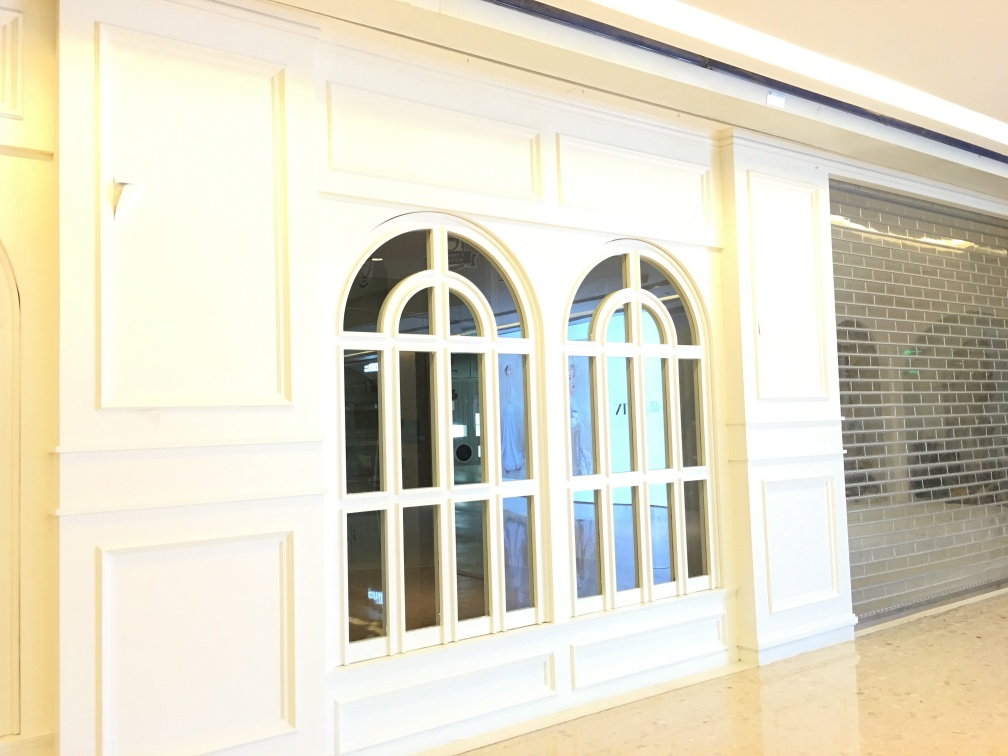Can you tell me about the lighting in this space? The lighting in the image is soft and diffuse, suggesting indirect natural lighting possibly coming from the opposite side, not visible here. The lack of harsh shadows and the bright, even illumination contribute to a calm and welcoming ambiance in this interior space. 